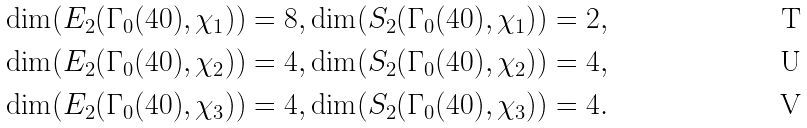<formula> <loc_0><loc_0><loc_500><loc_500>& \dim ( E _ { 2 } ( \Gamma _ { 0 } ( 4 0 ) , \chi _ { 1 } ) ) = 8 , \dim ( S _ { 2 } ( \Gamma _ { 0 } ( 4 0 ) , \chi _ { 1 } ) ) = 2 , \\ & \dim ( E _ { 2 } ( \Gamma _ { 0 } ( 4 0 ) , \chi _ { 2 } ) ) = 4 , \dim ( S _ { 2 } ( \Gamma _ { 0 } ( 4 0 ) , \chi _ { 2 } ) ) = 4 , \\ & \dim ( E _ { 2 } ( \Gamma _ { 0 } ( 4 0 ) , \chi _ { 3 } ) ) = 4 , \dim ( S _ { 2 } ( \Gamma _ { 0 } ( 4 0 ) , \chi _ { 3 } ) ) = 4 .</formula> 